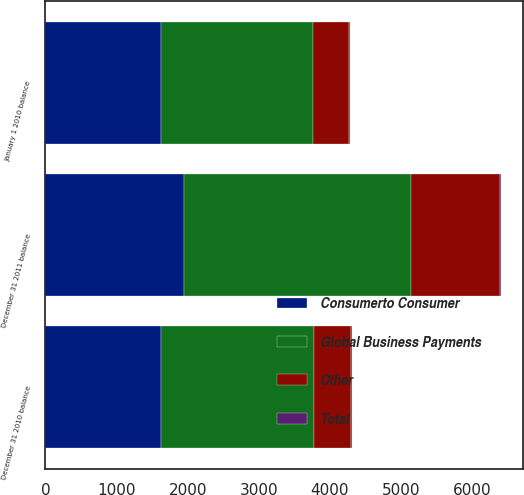Convert chart. <chart><loc_0><loc_0><loc_500><loc_500><stacked_bar_chart><ecel><fcel>January 1 2010 balance<fcel>December 31 2010 balance<fcel>December 31 2011 balance<nl><fcel>Consumerto Consumer<fcel>1619.9<fcel>1619.9<fcel>1945.3<nl><fcel>Other<fcel>509.2<fcel>517.6<fcel>1239.6<nl><fcel>Total<fcel>14.3<fcel>14.2<fcel>14<nl><fcel>Global Business Payments<fcel>2143.4<fcel>2151.7<fcel>3198.9<nl></chart> 